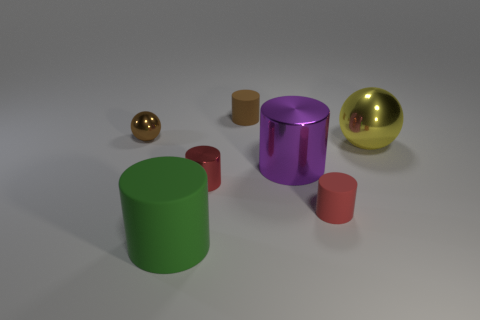Subtract all small yellow matte things. Subtract all large purple metallic cylinders. How many objects are left? 6 Add 2 small matte cylinders. How many small matte cylinders are left? 4 Add 4 red shiny things. How many red shiny things exist? 5 Add 3 small cubes. How many objects exist? 10 Subtract all green cylinders. How many cylinders are left? 4 Subtract all green cylinders. How many cylinders are left? 4 Subtract 0 green spheres. How many objects are left? 7 Subtract all balls. How many objects are left? 5 Subtract 2 balls. How many balls are left? 0 Subtract all gray cylinders. Subtract all yellow spheres. How many cylinders are left? 5 